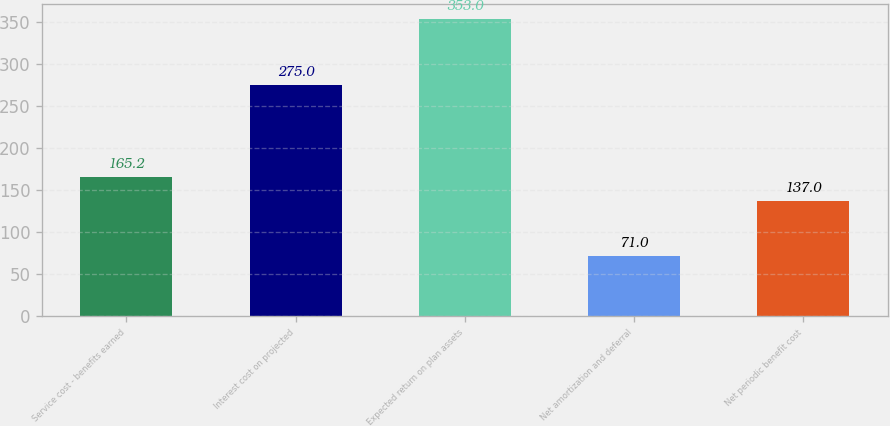<chart> <loc_0><loc_0><loc_500><loc_500><bar_chart><fcel>Service cost - benefits earned<fcel>Interest cost on projected<fcel>Expected return on plan assets<fcel>Net amortization and deferral<fcel>Net periodic benefit cost<nl><fcel>165.2<fcel>275<fcel>353<fcel>71<fcel>137<nl></chart> 